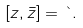Convert formula to latex. <formula><loc_0><loc_0><loc_500><loc_500>[ z , \bar { z } ] = \theta .</formula> 